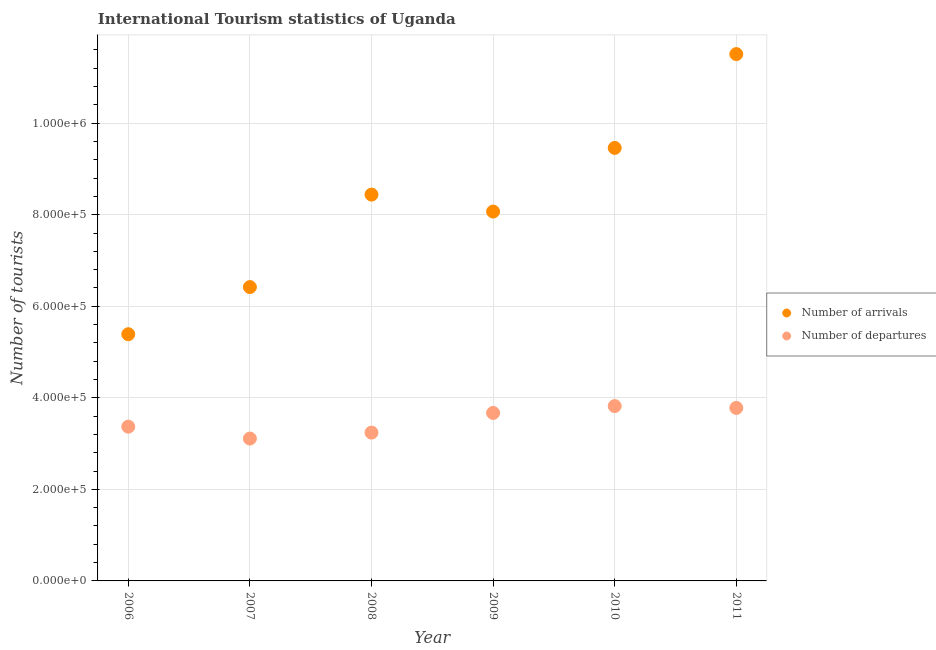How many different coloured dotlines are there?
Your response must be concise. 2. Is the number of dotlines equal to the number of legend labels?
Ensure brevity in your answer.  Yes. What is the number of tourist departures in 2008?
Provide a short and direct response. 3.24e+05. Across all years, what is the maximum number of tourist departures?
Give a very brief answer. 3.82e+05. Across all years, what is the minimum number of tourist arrivals?
Offer a very short reply. 5.39e+05. In which year was the number of tourist departures minimum?
Keep it short and to the point. 2007. What is the total number of tourist arrivals in the graph?
Ensure brevity in your answer.  4.93e+06. What is the difference between the number of tourist departures in 2007 and that in 2008?
Keep it short and to the point. -1.30e+04. What is the difference between the number of tourist arrivals in 2011 and the number of tourist departures in 2008?
Provide a short and direct response. 8.27e+05. What is the average number of tourist arrivals per year?
Offer a very short reply. 8.22e+05. In the year 2011, what is the difference between the number of tourist arrivals and number of tourist departures?
Your answer should be compact. 7.73e+05. In how many years, is the number of tourist departures greater than 1040000?
Your response must be concise. 0. What is the ratio of the number of tourist departures in 2009 to that in 2011?
Offer a very short reply. 0.97. Is the number of tourist departures in 2006 less than that in 2011?
Provide a short and direct response. Yes. What is the difference between the highest and the second highest number of tourist arrivals?
Offer a very short reply. 2.05e+05. What is the difference between the highest and the lowest number of tourist departures?
Keep it short and to the point. 7.10e+04. Is the sum of the number of tourist arrivals in 2006 and 2007 greater than the maximum number of tourist departures across all years?
Ensure brevity in your answer.  Yes. Are the values on the major ticks of Y-axis written in scientific E-notation?
Offer a terse response. Yes. Does the graph contain any zero values?
Offer a terse response. No. Where does the legend appear in the graph?
Provide a short and direct response. Center right. What is the title of the graph?
Your response must be concise. International Tourism statistics of Uganda. Does "Highest 10% of population" appear as one of the legend labels in the graph?
Keep it short and to the point. No. What is the label or title of the Y-axis?
Keep it short and to the point. Number of tourists. What is the Number of tourists of Number of arrivals in 2006?
Offer a terse response. 5.39e+05. What is the Number of tourists in Number of departures in 2006?
Provide a succinct answer. 3.37e+05. What is the Number of tourists in Number of arrivals in 2007?
Your answer should be very brief. 6.42e+05. What is the Number of tourists of Number of departures in 2007?
Offer a terse response. 3.11e+05. What is the Number of tourists of Number of arrivals in 2008?
Provide a short and direct response. 8.44e+05. What is the Number of tourists of Number of departures in 2008?
Offer a terse response. 3.24e+05. What is the Number of tourists of Number of arrivals in 2009?
Your answer should be very brief. 8.07e+05. What is the Number of tourists in Number of departures in 2009?
Your answer should be very brief. 3.67e+05. What is the Number of tourists of Number of arrivals in 2010?
Provide a succinct answer. 9.46e+05. What is the Number of tourists of Number of departures in 2010?
Ensure brevity in your answer.  3.82e+05. What is the Number of tourists of Number of arrivals in 2011?
Make the answer very short. 1.15e+06. What is the Number of tourists in Number of departures in 2011?
Give a very brief answer. 3.78e+05. Across all years, what is the maximum Number of tourists in Number of arrivals?
Give a very brief answer. 1.15e+06. Across all years, what is the maximum Number of tourists of Number of departures?
Your answer should be compact. 3.82e+05. Across all years, what is the minimum Number of tourists in Number of arrivals?
Provide a short and direct response. 5.39e+05. Across all years, what is the minimum Number of tourists in Number of departures?
Offer a terse response. 3.11e+05. What is the total Number of tourists in Number of arrivals in the graph?
Your answer should be compact. 4.93e+06. What is the total Number of tourists in Number of departures in the graph?
Give a very brief answer. 2.10e+06. What is the difference between the Number of tourists of Number of arrivals in 2006 and that in 2007?
Make the answer very short. -1.03e+05. What is the difference between the Number of tourists in Number of departures in 2006 and that in 2007?
Offer a terse response. 2.60e+04. What is the difference between the Number of tourists of Number of arrivals in 2006 and that in 2008?
Your response must be concise. -3.05e+05. What is the difference between the Number of tourists in Number of departures in 2006 and that in 2008?
Offer a very short reply. 1.30e+04. What is the difference between the Number of tourists of Number of arrivals in 2006 and that in 2009?
Your response must be concise. -2.68e+05. What is the difference between the Number of tourists in Number of arrivals in 2006 and that in 2010?
Make the answer very short. -4.07e+05. What is the difference between the Number of tourists in Number of departures in 2006 and that in 2010?
Ensure brevity in your answer.  -4.50e+04. What is the difference between the Number of tourists in Number of arrivals in 2006 and that in 2011?
Offer a very short reply. -6.12e+05. What is the difference between the Number of tourists in Number of departures in 2006 and that in 2011?
Your answer should be compact. -4.10e+04. What is the difference between the Number of tourists of Number of arrivals in 2007 and that in 2008?
Offer a terse response. -2.02e+05. What is the difference between the Number of tourists of Number of departures in 2007 and that in 2008?
Make the answer very short. -1.30e+04. What is the difference between the Number of tourists in Number of arrivals in 2007 and that in 2009?
Ensure brevity in your answer.  -1.65e+05. What is the difference between the Number of tourists of Number of departures in 2007 and that in 2009?
Your response must be concise. -5.60e+04. What is the difference between the Number of tourists in Number of arrivals in 2007 and that in 2010?
Your answer should be very brief. -3.04e+05. What is the difference between the Number of tourists in Number of departures in 2007 and that in 2010?
Offer a very short reply. -7.10e+04. What is the difference between the Number of tourists in Number of arrivals in 2007 and that in 2011?
Make the answer very short. -5.09e+05. What is the difference between the Number of tourists of Number of departures in 2007 and that in 2011?
Your answer should be compact. -6.70e+04. What is the difference between the Number of tourists in Number of arrivals in 2008 and that in 2009?
Make the answer very short. 3.70e+04. What is the difference between the Number of tourists of Number of departures in 2008 and that in 2009?
Offer a terse response. -4.30e+04. What is the difference between the Number of tourists of Number of arrivals in 2008 and that in 2010?
Your answer should be very brief. -1.02e+05. What is the difference between the Number of tourists in Number of departures in 2008 and that in 2010?
Keep it short and to the point. -5.80e+04. What is the difference between the Number of tourists of Number of arrivals in 2008 and that in 2011?
Your response must be concise. -3.07e+05. What is the difference between the Number of tourists of Number of departures in 2008 and that in 2011?
Your answer should be very brief. -5.40e+04. What is the difference between the Number of tourists in Number of arrivals in 2009 and that in 2010?
Provide a short and direct response. -1.39e+05. What is the difference between the Number of tourists in Number of departures in 2009 and that in 2010?
Offer a terse response. -1.50e+04. What is the difference between the Number of tourists in Number of arrivals in 2009 and that in 2011?
Keep it short and to the point. -3.44e+05. What is the difference between the Number of tourists in Number of departures in 2009 and that in 2011?
Provide a succinct answer. -1.10e+04. What is the difference between the Number of tourists in Number of arrivals in 2010 and that in 2011?
Offer a terse response. -2.05e+05. What is the difference between the Number of tourists of Number of departures in 2010 and that in 2011?
Your answer should be compact. 4000. What is the difference between the Number of tourists in Number of arrivals in 2006 and the Number of tourists in Number of departures in 2007?
Offer a terse response. 2.28e+05. What is the difference between the Number of tourists of Number of arrivals in 2006 and the Number of tourists of Number of departures in 2008?
Ensure brevity in your answer.  2.15e+05. What is the difference between the Number of tourists in Number of arrivals in 2006 and the Number of tourists in Number of departures in 2009?
Offer a very short reply. 1.72e+05. What is the difference between the Number of tourists of Number of arrivals in 2006 and the Number of tourists of Number of departures in 2010?
Give a very brief answer. 1.57e+05. What is the difference between the Number of tourists of Number of arrivals in 2006 and the Number of tourists of Number of departures in 2011?
Keep it short and to the point. 1.61e+05. What is the difference between the Number of tourists in Number of arrivals in 2007 and the Number of tourists in Number of departures in 2008?
Ensure brevity in your answer.  3.18e+05. What is the difference between the Number of tourists in Number of arrivals in 2007 and the Number of tourists in Number of departures in 2009?
Offer a terse response. 2.75e+05. What is the difference between the Number of tourists of Number of arrivals in 2007 and the Number of tourists of Number of departures in 2011?
Provide a succinct answer. 2.64e+05. What is the difference between the Number of tourists of Number of arrivals in 2008 and the Number of tourists of Number of departures in 2009?
Your answer should be very brief. 4.77e+05. What is the difference between the Number of tourists in Number of arrivals in 2008 and the Number of tourists in Number of departures in 2010?
Provide a short and direct response. 4.62e+05. What is the difference between the Number of tourists in Number of arrivals in 2008 and the Number of tourists in Number of departures in 2011?
Ensure brevity in your answer.  4.66e+05. What is the difference between the Number of tourists of Number of arrivals in 2009 and the Number of tourists of Number of departures in 2010?
Offer a very short reply. 4.25e+05. What is the difference between the Number of tourists in Number of arrivals in 2009 and the Number of tourists in Number of departures in 2011?
Make the answer very short. 4.29e+05. What is the difference between the Number of tourists of Number of arrivals in 2010 and the Number of tourists of Number of departures in 2011?
Your answer should be compact. 5.68e+05. What is the average Number of tourists of Number of arrivals per year?
Your answer should be compact. 8.22e+05. What is the average Number of tourists of Number of departures per year?
Provide a succinct answer. 3.50e+05. In the year 2006, what is the difference between the Number of tourists in Number of arrivals and Number of tourists in Number of departures?
Provide a succinct answer. 2.02e+05. In the year 2007, what is the difference between the Number of tourists of Number of arrivals and Number of tourists of Number of departures?
Ensure brevity in your answer.  3.31e+05. In the year 2008, what is the difference between the Number of tourists of Number of arrivals and Number of tourists of Number of departures?
Make the answer very short. 5.20e+05. In the year 2010, what is the difference between the Number of tourists in Number of arrivals and Number of tourists in Number of departures?
Provide a short and direct response. 5.64e+05. In the year 2011, what is the difference between the Number of tourists in Number of arrivals and Number of tourists in Number of departures?
Provide a short and direct response. 7.73e+05. What is the ratio of the Number of tourists of Number of arrivals in 2006 to that in 2007?
Your answer should be very brief. 0.84. What is the ratio of the Number of tourists in Number of departures in 2006 to that in 2007?
Give a very brief answer. 1.08. What is the ratio of the Number of tourists of Number of arrivals in 2006 to that in 2008?
Your answer should be compact. 0.64. What is the ratio of the Number of tourists of Number of departures in 2006 to that in 2008?
Your answer should be very brief. 1.04. What is the ratio of the Number of tourists of Number of arrivals in 2006 to that in 2009?
Your answer should be compact. 0.67. What is the ratio of the Number of tourists of Number of departures in 2006 to that in 2009?
Provide a short and direct response. 0.92. What is the ratio of the Number of tourists in Number of arrivals in 2006 to that in 2010?
Your answer should be very brief. 0.57. What is the ratio of the Number of tourists in Number of departures in 2006 to that in 2010?
Your answer should be very brief. 0.88. What is the ratio of the Number of tourists in Number of arrivals in 2006 to that in 2011?
Your answer should be compact. 0.47. What is the ratio of the Number of tourists of Number of departures in 2006 to that in 2011?
Give a very brief answer. 0.89. What is the ratio of the Number of tourists in Number of arrivals in 2007 to that in 2008?
Your answer should be compact. 0.76. What is the ratio of the Number of tourists in Number of departures in 2007 to that in 2008?
Offer a terse response. 0.96. What is the ratio of the Number of tourists in Number of arrivals in 2007 to that in 2009?
Ensure brevity in your answer.  0.8. What is the ratio of the Number of tourists of Number of departures in 2007 to that in 2009?
Ensure brevity in your answer.  0.85. What is the ratio of the Number of tourists of Number of arrivals in 2007 to that in 2010?
Offer a very short reply. 0.68. What is the ratio of the Number of tourists in Number of departures in 2007 to that in 2010?
Your answer should be compact. 0.81. What is the ratio of the Number of tourists in Number of arrivals in 2007 to that in 2011?
Provide a short and direct response. 0.56. What is the ratio of the Number of tourists of Number of departures in 2007 to that in 2011?
Give a very brief answer. 0.82. What is the ratio of the Number of tourists of Number of arrivals in 2008 to that in 2009?
Offer a terse response. 1.05. What is the ratio of the Number of tourists in Number of departures in 2008 to that in 2009?
Provide a short and direct response. 0.88. What is the ratio of the Number of tourists of Number of arrivals in 2008 to that in 2010?
Ensure brevity in your answer.  0.89. What is the ratio of the Number of tourists of Number of departures in 2008 to that in 2010?
Provide a succinct answer. 0.85. What is the ratio of the Number of tourists of Number of arrivals in 2008 to that in 2011?
Ensure brevity in your answer.  0.73. What is the ratio of the Number of tourists in Number of departures in 2008 to that in 2011?
Your response must be concise. 0.86. What is the ratio of the Number of tourists of Number of arrivals in 2009 to that in 2010?
Give a very brief answer. 0.85. What is the ratio of the Number of tourists in Number of departures in 2009 to that in 2010?
Offer a terse response. 0.96. What is the ratio of the Number of tourists in Number of arrivals in 2009 to that in 2011?
Offer a very short reply. 0.7. What is the ratio of the Number of tourists in Number of departures in 2009 to that in 2011?
Give a very brief answer. 0.97. What is the ratio of the Number of tourists of Number of arrivals in 2010 to that in 2011?
Give a very brief answer. 0.82. What is the ratio of the Number of tourists in Number of departures in 2010 to that in 2011?
Offer a very short reply. 1.01. What is the difference between the highest and the second highest Number of tourists of Number of arrivals?
Provide a short and direct response. 2.05e+05. What is the difference between the highest and the second highest Number of tourists of Number of departures?
Make the answer very short. 4000. What is the difference between the highest and the lowest Number of tourists of Number of arrivals?
Offer a very short reply. 6.12e+05. What is the difference between the highest and the lowest Number of tourists of Number of departures?
Keep it short and to the point. 7.10e+04. 